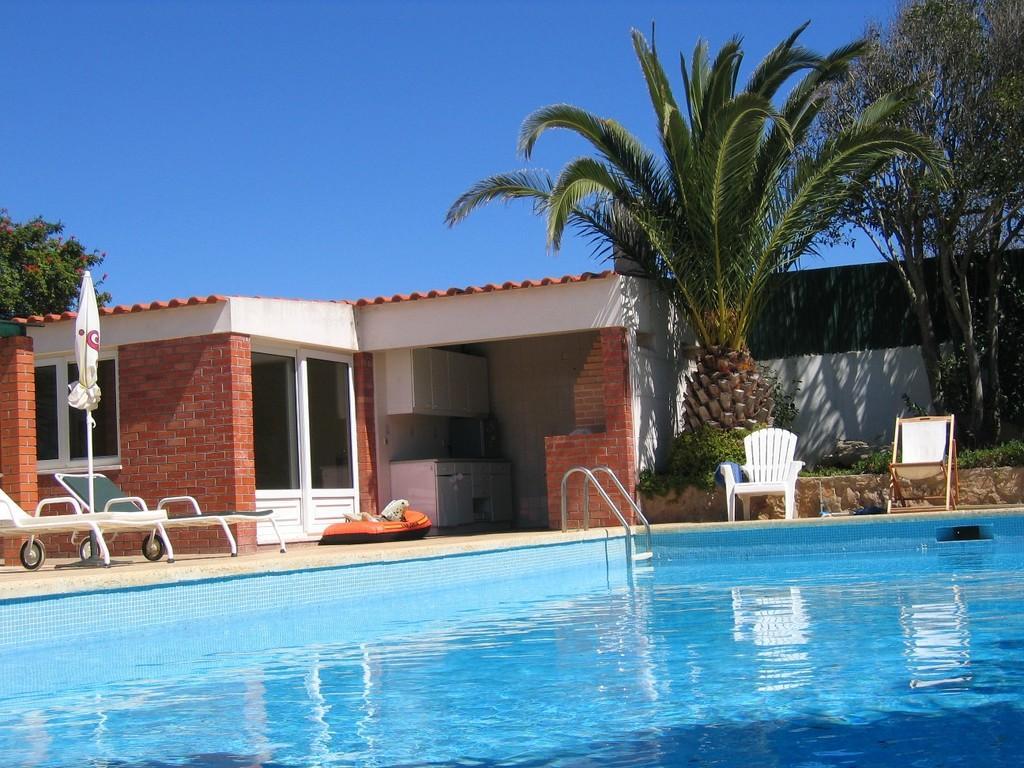How would you summarize this image in a sentence or two? In this picture there is a swimming pool in the center of the image and there are chair around it, there is an umbrella on the left side of the image, there is a room in the background area of the image and there are trees on the right and left side of the image. 